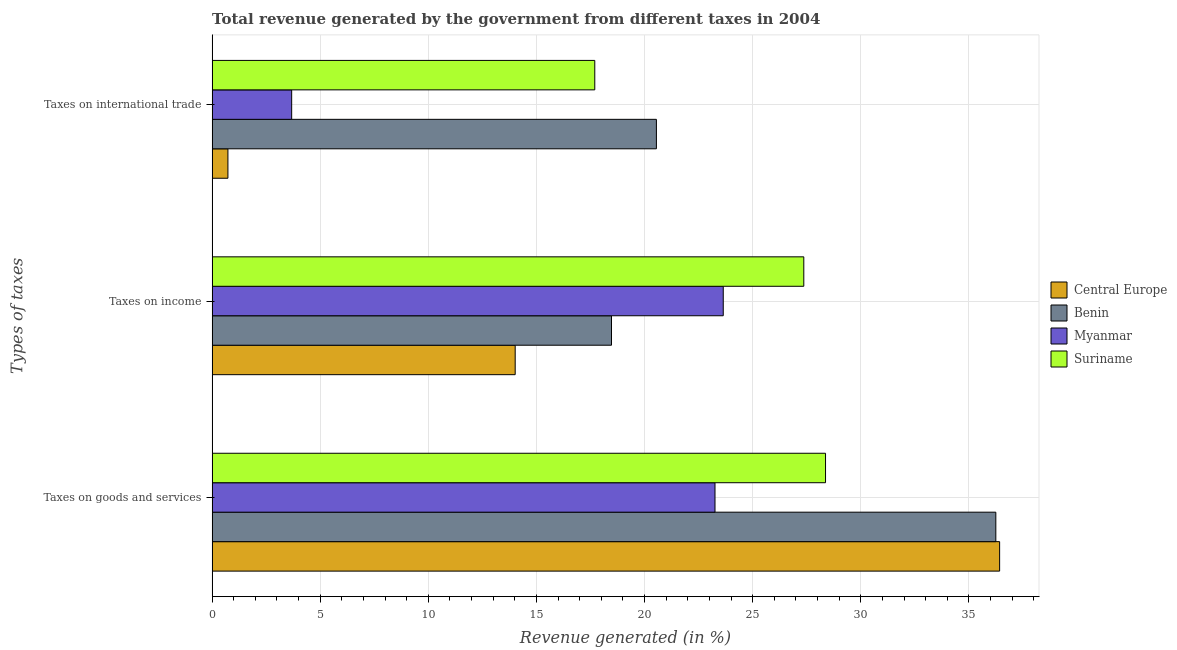Are the number of bars on each tick of the Y-axis equal?
Your answer should be compact. Yes. How many bars are there on the 2nd tick from the bottom?
Your response must be concise. 4. What is the label of the 3rd group of bars from the top?
Your response must be concise. Taxes on goods and services. What is the percentage of revenue generated by taxes on income in Myanmar?
Your answer should be compact. 23.64. Across all countries, what is the maximum percentage of revenue generated by tax on international trade?
Give a very brief answer. 20.55. Across all countries, what is the minimum percentage of revenue generated by tax on international trade?
Give a very brief answer. 0.73. In which country was the percentage of revenue generated by taxes on income maximum?
Your response must be concise. Suriname. In which country was the percentage of revenue generated by taxes on income minimum?
Your answer should be compact. Central Europe. What is the total percentage of revenue generated by taxes on income in the graph?
Ensure brevity in your answer.  83.49. What is the difference between the percentage of revenue generated by taxes on goods and services in Suriname and that in Benin?
Your response must be concise. -7.88. What is the difference between the percentage of revenue generated by taxes on goods and services in Benin and the percentage of revenue generated by tax on international trade in Myanmar?
Offer a terse response. 32.57. What is the average percentage of revenue generated by tax on international trade per country?
Make the answer very short. 10.66. What is the difference between the percentage of revenue generated by taxes on goods and services and percentage of revenue generated by taxes on income in Central Europe?
Make the answer very short. 22.4. In how many countries, is the percentage of revenue generated by taxes on income greater than 2 %?
Make the answer very short. 4. What is the ratio of the percentage of revenue generated by taxes on income in Benin to that in Myanmar?
Provide a succinct answer. 0.78. Is the percentage of revenue generated by tax on international trade in Central Europe less than that in Benin?
Your answer should be very brief. Yes. Is the difference between the percentage of revenue generated by taxes on goods and services in Benin and Myanmar greater than the difference between the percentage of revenue generated by taxes on income in Benin and Myanmar?
Keep it short and to the point. Yes. What is the difference between the highest and the second highest percentage of revenue generated by taxes on income?
Offer a terse response. 3.73. What is the difference between the highest and the lowest percentage of revenue generated by taxes on goods and services?
Offer a very short reply. 13.16. In how many countries, is the percentage of revenue generated by taxes on goods and services greater than the average percentage of revenue generated by taxes on goods and services taken over all countries?
Make the answer very short. 2. What does the 3rd bar from the top in Taxes on income represents?
Keep it short and to the point. Benin. What does the 2nd bar from the bottom in Taxes on international trade represents?
Offer a terse response. Benin. Is it the case that in every country, the sum of the percentage of revenue generated by taxes on goods and services and percentage of revenue generated by taxes on income is greater than the percentage of revenue generated by tax on international trade?
Your response must be concise. Yes. Are all the bars in the graph horizontal?
Make the answer very short. Yes. What is the difference between two consecutive major ticks on the X-axis?
Make the answer very short. 5. Are the values on the major ticks of X-axis written in scientific E-notation?
Make the answer very short. No. How are the legend labels stacked?
Your answer should be compact. Vertical. What is the title of the graph?
Make the answer very short. Total revenue generated by the government from different taxes in 2004. What is the label or title of the X-axis?
Provide a succinct answer. Revenue generated (in %). What is the label or title of the Y-axis?
Give a very brief answer. Types of taxes. What is the Revenue generated (in %) of Central Europe in Taxes on goods and services?
Provide a short and direct response. 36.42. What is the Revenue generated (in %) in Benin in Taxes on goods and services?
Offer a very short reply. 36.24. What is the Revenue generated (in %) of Myanmar in Taxes on goods and services?
Your answer should be compact. 23.26. What is the Revenue generated (in %) in Suriname in Taxes on goods and services?
Your answer should be compact. 28.37. What is the Revenue generated (in %) of Central Europe in Taxes on income?
Your answer should be compact. 14.02. What is the Revenue generated (in %) in Benin in Taxes on income?
Provide a succinct answer. 18.47. What is the Revenue generated (in %) in Myanmar in Taxes on income?
Provide a short and direct response. 23.64. What is the Revenue generated (in %) of Suriname in Taxes on income?
Your response must be concise. 27.36. What is the Revenue generated (in %) of Central Europe in Taxes on international trade?
Offer a terse response. 0.73. What is the Revenue generated (in %) in Benin in Taxes on international trade?
Make the answer very short. 20.55. What is the Revenue generated (in %) in Myanmar in Taxes on international trade?
Offer a very short reply. 3.68. What is the Revenue generated (in %) of Suriname in Taxes on international trade?
Your response must be concise. 17.7. Across all Types of taxes, what is the maximum Revenue generated (in %) in Central Europe?
Make the answer very short. 36.42. Across all Types of taxes, what is the maximum Revenue generated (in %) of Benin?
Keep it short and to the point. 36.24. Across all Types of taxes, what is the maximum Revenue generated (in %) of Myanmar?
Give a very brief answer. 23.64. Across all Types of taxes, what is the maximum Revenue generated (in %) of Suriname?
Your answer should be compact. 28.37. Across all Types of taxes, what is the minimum Revenue generated (in %) of Central Europe?
Provide a succinct answer. 0.73. Across all Types of taxes, what is the minimum Revenue generated (in %) in Benin?
Make the answer very short. 18.47. Across all Types of taxes, what is the minimum Revenue generated (in %) of Myanmar?
Provide a short and direct response. 3.68. Across all Types of taxes, what is the minimum Revenue generated (in %) in Suriname?
Ensure brevity in your answer.  17.7. What is the total Revenue generated (in %) in Central Europe in the graph?
Offer a terse response. 51.17. What is the total Revenue generated (in %) in Benin in the graph?
Your answer should be compact. 75.26. What is the total Revenue generated (in %) of Myanmar in the graph?
Offer a terse response. 50.57. What is the total Revenue generated (in %) in Suriname in the graph?
Offer a very short reply. 73.43. What is the difference between the Revenue generated (in %) in Central Europe in Taxes on goods and services and that in Taxes on income?
Keep it short and to the point. 22.4. What is the difference between the Revenue generated (in %) in Benin in Taxes on goods and services and that in Taxes on income?
Give a very brief answer. 17.77. What is the difference between the Revenue generated (in %) in Myanmar in Taxes on goods and services and that in Taxes on income?
Give a very brief answer. -0.38. What is the difference between the Revenue generated (in %) in Suriname in Taxes on goods and services and that in Taxes on income?
Provide a short and direct response. 1.01. What is the difference between the Revenue generated (in %) of Central Europe in Taxes on goods and services and that in Taxes on international trade?
Keep it short and to the point. 35.69. What is the difference between the Revenue generated (in %) of Benin in Taxes on goods and services and that in Taxes on international trade?
Give a very brief answer. 15.7. What is the difference between the Revenue generated (in %) of Myanmar in Taxes on goods and services and that in Taxes on international trade?
Provide a short and direct response. 19.58. What is the difference between the Revenue generated (in %) in Suriname in Taxes on goods and services and that in Taxes on international trade?
Give a very brief answer. 10.67. What is the difference between the Revenue generated (in %) of Central Europe in Taxes on income and that in Taxes on international trade?
Your answer should be compact. 13.29. What is the difference between the Revenue generated (in %) of Benin in Taxes on income and that in Taxes on international trade?
Your response must be concise. -2.08. What is the difference between the Revenue generated (in %) in Myanmar in Taxes on income and that in Taxes on international trade?
Give a very brief answer. 19.96. What is the difference between the Revenue generated (in %) in Suriname in Taxes on income and that in Taxes on international trade?
Offer a terse response. 9.67. What is the difference between the Revenue generated (in %) in Central Europe in Taxes on goods and services and the Revenue generated (in %) in Benin in Taxes on income?
Give a very brief answer. 17.95. What is the difference between the Revenue generated (in %) of Central Europe in Taxes on goods and services and the Revenue generated (in %) of Myanmar in Taxes on income?
Offer a terse response. 12.78. What is the difference between the Revenue generated (in %) in Central Europe in Taxes on goods and services and the Revenue generated (in %) in Suriname in Taxes on income?
Offer a very short reply. 9.06. What is the difference between the Revenue generated (in %) in Benin in Taxes on goods and services and the Revenue generated (in %) in Myanmar in Taxes on income?
Make the answer very short. 12.61. What is the difference between the Revenue generated (in %) of Benin in Taxes on goods and services and the Revenue generated (in %) of Suriname in Taxes on income?
Offer a terse response. 8.88. What is the difference between the Revenue generated (in %) in Myanmar in Taxes on goods and services and the Revenue generated (in %) in Suriname in Taxes on income?
Offer a terse response. -4.11. What is the difference between the Revenue generated (in %) of Central Europe in Taxes on goods and services and the Revenue generated (in %) of Benin in Taxes on international trade?
Offer a very short reply. 15.87. What is the difference between the Revenue generated (in %) of Central Europe in Taxes on goods and services and the Revenue generated (in %) of Myanmar in Taxes on international trade?
Provide a short and direct response. 32.74. What is the difference between the Revenue generated (in %) in Central Europe in Taxes on goods and services and the Revenue generated (in %) in Suriname in Taxes on international trade?
Your answer should be very brief. 18.72. What is the difference between the Revenue generated (in %) of Benin in Taxes on goods and services and the Revenue generated (in %) of Myanmar in Taxes on international trade?
Your answer should be compact. 32.57. What is the difference between the Revenue generated (in %) in Benin in Taxes on goods and services and the Revenue generated (in %) in Suriname in Taxes on international trade?
Provide a short and direct response. 18.55. What is the difference between the Revenue generated (in %) in Myanmar in Taxes on goods and services and the Revenue generated (in %) in Suriname in Taxes on international trade?
Make the answer very short. 5.56. What is the difference between the Revenue generated (in %) of Central Europe in Taxes on income and the Revenue generated (in %) of Benin in Taxes on international trade?
Your answer should be compact. -6.53. What is the difference between the Revenue generated (in %) in Central Europe in Taxes on income and the Revenue generated (in %) in Myanmar in Taxes on international trade?
Provide a succinct answer. 10.34. What is the difference between the Revenue generated (in %) in Central Europe in Taxes on income and the Revenue generated (in %) in Suriname in Taxes on international trade?
Your response must be concise. -3.68. What is the difference between the Revenue generated (in %) in Benin in Taxes on income and the Revenue generated (in %) in Myanmar in Taxes on international trade?
Give a very brief answer. 14.79. What is the difference between the Revenue generated (in %) of Benin in Taxes on income and the Revenue generated (in %) of Suriname in Taxes on international trade?
Your answer should be very brief. 0.77. What is the difference between the Revenue generated (in %) of Myanmar in Taxes on income and the Revenue generated (in %) of Suriname in Taxes on international trade?
Your answer should be compact. 5.94. What is the average Revenue generated (in %) in Central Europe per Types of taxes?
Keep it short and to the point. 17.06. What is the average Revenue generated (in %) of Benin per Types of taxes?
Provide a succinct answer. 25.09. What is the average Revenue generated (in %) of Myanmar per Types of taxes?
Keep it short and to the point. 16.86. What is the average Revenue generated (in %) of Suriname per Types of taxes?
Give a very brief answer. 24.48. What is the difference between the Revenue generated (in %) in Central Europe and Revenue generated (in %) in Benin in Taxes on goods and services?
Offer a terse response. 0.17. What is the difference between the Revenue generated (in %) of Central Europe and Revenue generated (in %) of Myanmar in Taxes on goods and services?
Ensure brevity in your answer.  13.16. What is the difference between the Revenue generated (in %) in Central Europe and Revenue generated (in %) in Suriname in Taxes on goods and services?
Give a very brief answer. 8.05. What is the difference between the Revenue generated (in %) of Benin and Revenue generated (in %) of Myanmar in Taxes on goods and services?
Give a very brief answer. 12.99. What is the difference between the Revenue generated (in %) of Benin and Revenue generated (in %) of Suriname in Taxes on goods and services?
Make the answer very short. 7.88. What is the difference between the Revenue generated (in %) in Myanmar and Revenue generated (in %) in Suriname in Taxes on goods and services?
Provide a succinct answer. -5.11. What is the difference between the Revenue generated (in %) of Central Europe and Revenue generated (in %) of Benin in Taxes on income?
Your answer should be very brief. -4.45. What is the difference between the Revenue generated (in %) of Central Europe and Revenue generated (in %) of Myanmar in Taxes on income?
Give a very brief answer. -9.62. What is the difference between the Revenue generated (in %) in Central Europe and Revenue generated (in %) in Suriname in Taxes on income?
Your answer should be very brief. -13.35. What is the difference between the Revenue generated (in %) in Benin and Revenue generated (in %) in Myanmar in Taxes on income?
Ensure brevity in your answer.  -5.17. What is the difference between the Revenue generated (in %) of Benin and Revenue generated (in %) of Suriname in Taxes on income?
Offer a terse response. -8.89. What is the difference between the Revenue generated (in %) of Myanmar and Revenue generated (in %) of Suriname in Taxes on income?
Offer a very short reply. -3.73. What is the difference between the Revenue generated (in %) of Central Europe and Revenue generated (in %) of Benin in Taxes on international trade?
Your answer should be compact. -19.82. What is the difference between the Revenue generated (in %) in Central Europe and Revenue generated (in %) in Myanmar in Taxes on international trade?
Make the answer very short. -2.95. What is the difference between the Revenue generated (in %) of Central Europe and Revenue generated (in %) of Suriname in Taxes on international trade?
Offer a very short reply. -16.97. What is the difference between the Revenue generated (in %) of Benin and Revenue generated (in %) of Myanmar in Taxes on international trade?
Offer a terse response. 16.87. What is the difference between the Revenue generated (in %) of Benin and Revenue generated (in %) of Suriname in Taxes on international trade?
Offer a very short reply. 2.85. What is the difference between the Revenue generated (in %) in Myanmar and Revenue generated (in %) in Suriname in Taxes on international trade?
Offer a very short reply. -14.02. What is the ratio of the Revenue generated (in %) of Central Europe in Taxes on goods and services to that in Taxes on income?
Your answer should be compact. 2.6. What is the ratio of the Revenue generated (in %) of Benin in Taxes on goods and services to that in Taxes on income?
Offer a terse response. 1.96. What is the ratio of the Revenue generated (in %) of Myanmar in Taxes on goods and services to that in Taxes on income?
Ensure brevity in your answer.  0.98. What is the ratio of the Revenue generated (in %) of Suriname in Taxes on goods and services to that in Taxes on income?
Make the answer very short. 1.04. What is the ratio of the Revenue generated (in %) in Central Europe in Taxes on goods and services to that in Taxes on international trade?
Offer a very short reply. 49.85. What is the ratio of the Revenue generated (in %) in Benin in Taxes on goods and services to that in Taxes on international trade?
Make the answer very short. 1.76. What is the ratio of the Revenue generated (in %) of Myanmar in Taxes on goods and services to that in Taxes on international trade?
Make the answer very short. 6.32. What is the ratio of the Revenue generated (in %) in Suriname in Taxes on goods and services to that in Taxes on international trade?
Your answer should be compact. 1.6. What is the ratio of the Revenue generated (in %) of Central Europe in Taxes on income to that in Taxes on international trade?
Give a very brief answer. 19.18. What is the ratio of the Revenue generated (in %) in Benin in Taxes on income to that in Taxes on international trade?
Make the answer very short. 0.9. What is the ratio of the Revenue generated (in %) in Myanmar in Taxes on income to that in Taxes on international trade?
Provide a succinct answer. 6.43. What is the ratio of the Revenue generated (in %) of Suriname in Taxes on income to that in Taxes on international trade?
Offer a terse response. 1.55. What is the difference between the highest and the second highest Revenue generated (in %) of Central Europe?
Your answer should be compact. 22.4. What is the difference between the highest and the second highest Revenue generated (in %) of Benin?
Give a very brief answer. 15.7. What is the difference between the highest and the second highest Revenue generated (in %) of Myanmar?
Ensure brevity in your answer.  0.38. What is the difference between the highest and the second highest Revenue generated (in %) of Suriname?
Offer a very short reply. 1.01. What is the difference between the highest and the lowest Revenue generated (in %) in Central Europe?
Offer a terse response. 35.69. What is the difference between the highest and the lowest Revenue generated (in %) in Benin?
Provide a succinct answer. 17.77. What is the difference between the highest and the lowest Revenue generated (in %) in Myanmar?
Offer a terse response. 19.96. What is the difference between the highest and the lowest Revenue generated (in %) in Suriname?
Offer a very short reply. 10.67. 